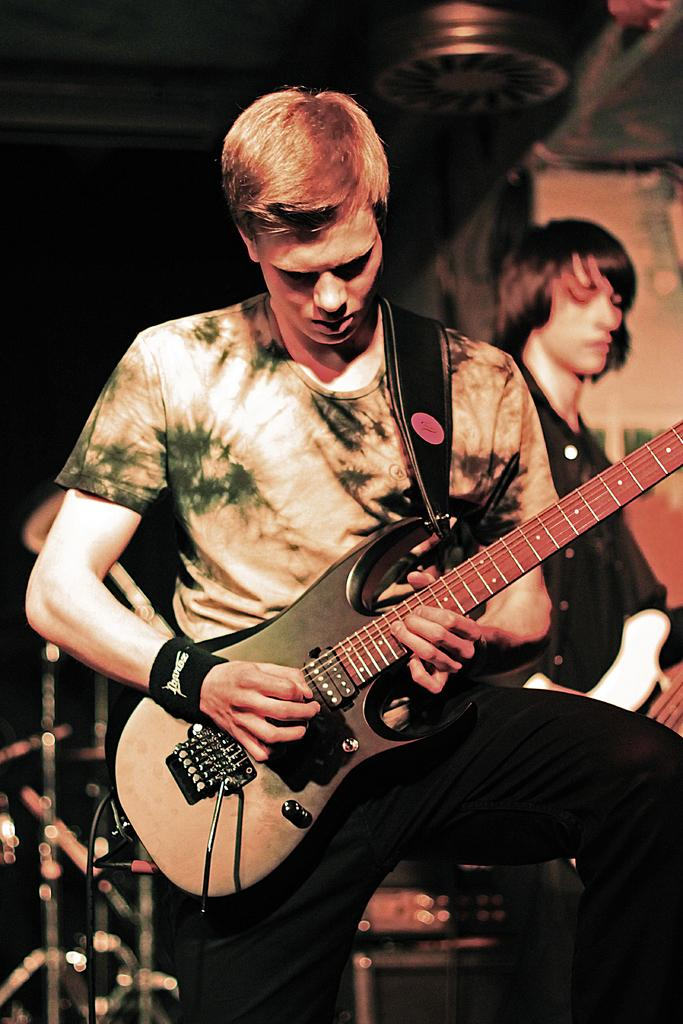Who is the main subject in the image? There is a man in the image. What is the man holding in the image? The man is holding a guitar. What is the man doing with the guitar? The man is playing the guitar. What can be seen in the background of the image? There is an electronic drum set and a person in the background of the image. What type of mint is the man chewing while playing the guitar in the image? There is no mint present in the image, and the man is not chewing anything. 